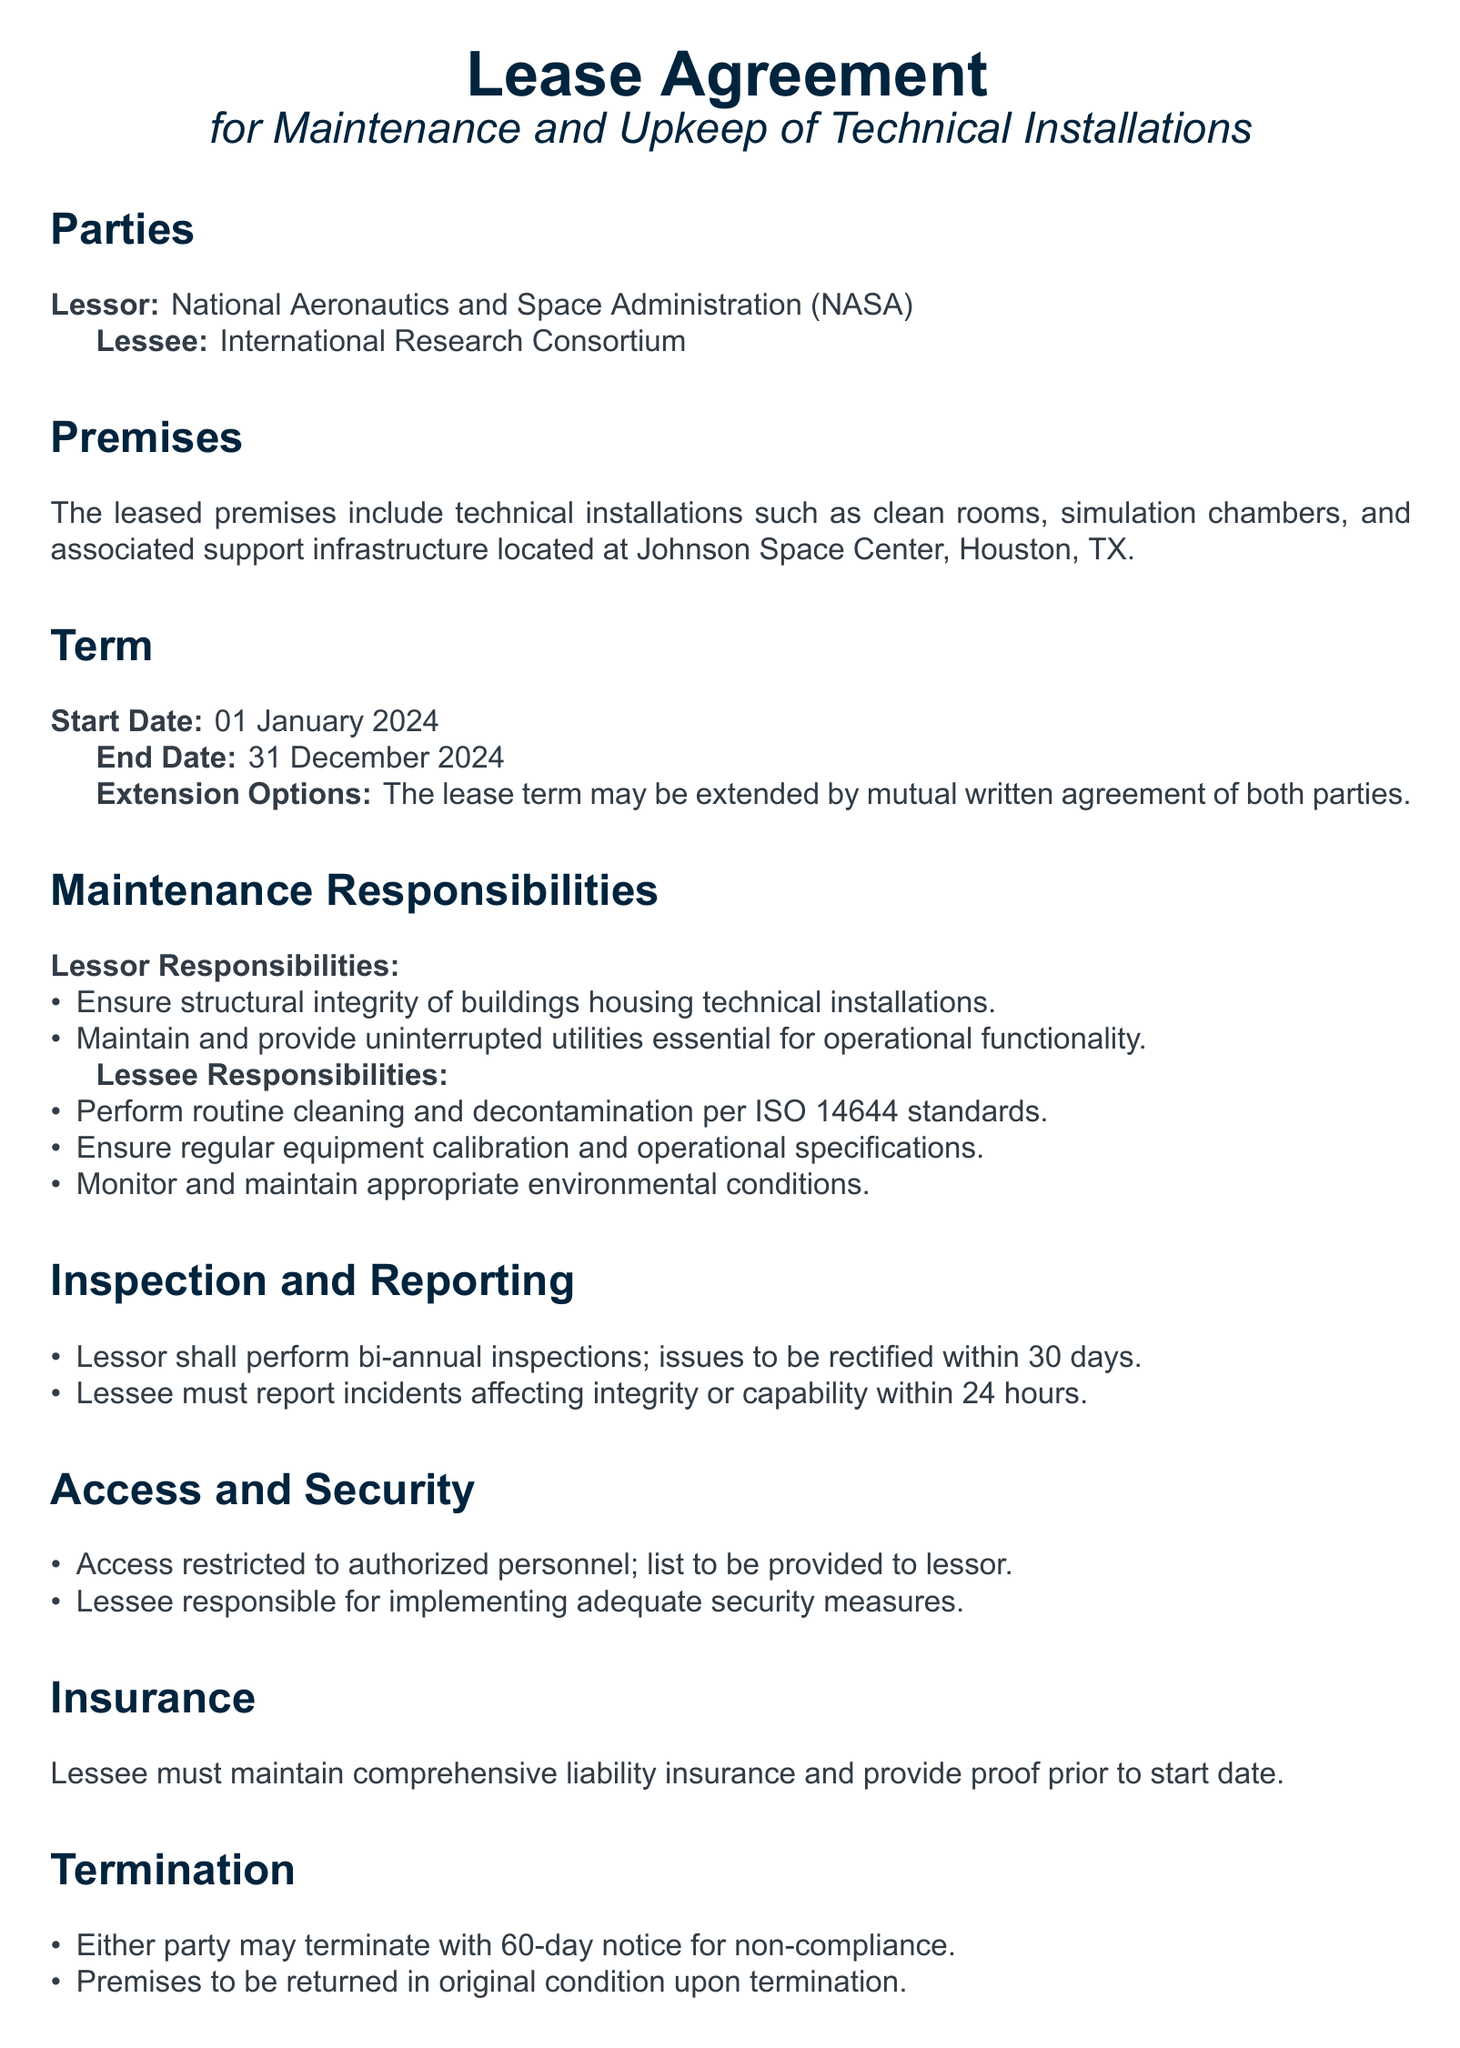what is the start date of the lease? The start date of the lease is explicitly stated in the document as the beginning of the term.
Answer: 01 January 2024 who is the lessor? The lessor is the party responsible for the premises and is named directly in the document.
Answer: National Aeronautics and Space Administration (NASA) what are the lessee's responsibilities? The lessee's responsibilities are outlined in a list format within the document, specifying their obligations.
Answer: Routine cleaning and decontamination per ISO 14644 standards how long is the lease term? The lease term duration can be determined by the start and end dates provided in the document.
Answer: 12 months how many inspections will the lessor perform? This number is specified within the inspection and reporting section of the document.
Answer: Bi-annual when can either party terminate the lease? The conditions for termination are stated specifically in the corresponding section of the document.
Answer: With 60-day notice for non-compliance what type of insurance must the lessee maintain? The document mentions the requirement for the type of insurance needed by the lessee.
Answer: Comprehensive liability insurance what is the lessee's title? The title of the lessee's representative is mentioned at the end in the signature section.
Answer: Project Director, IRC 